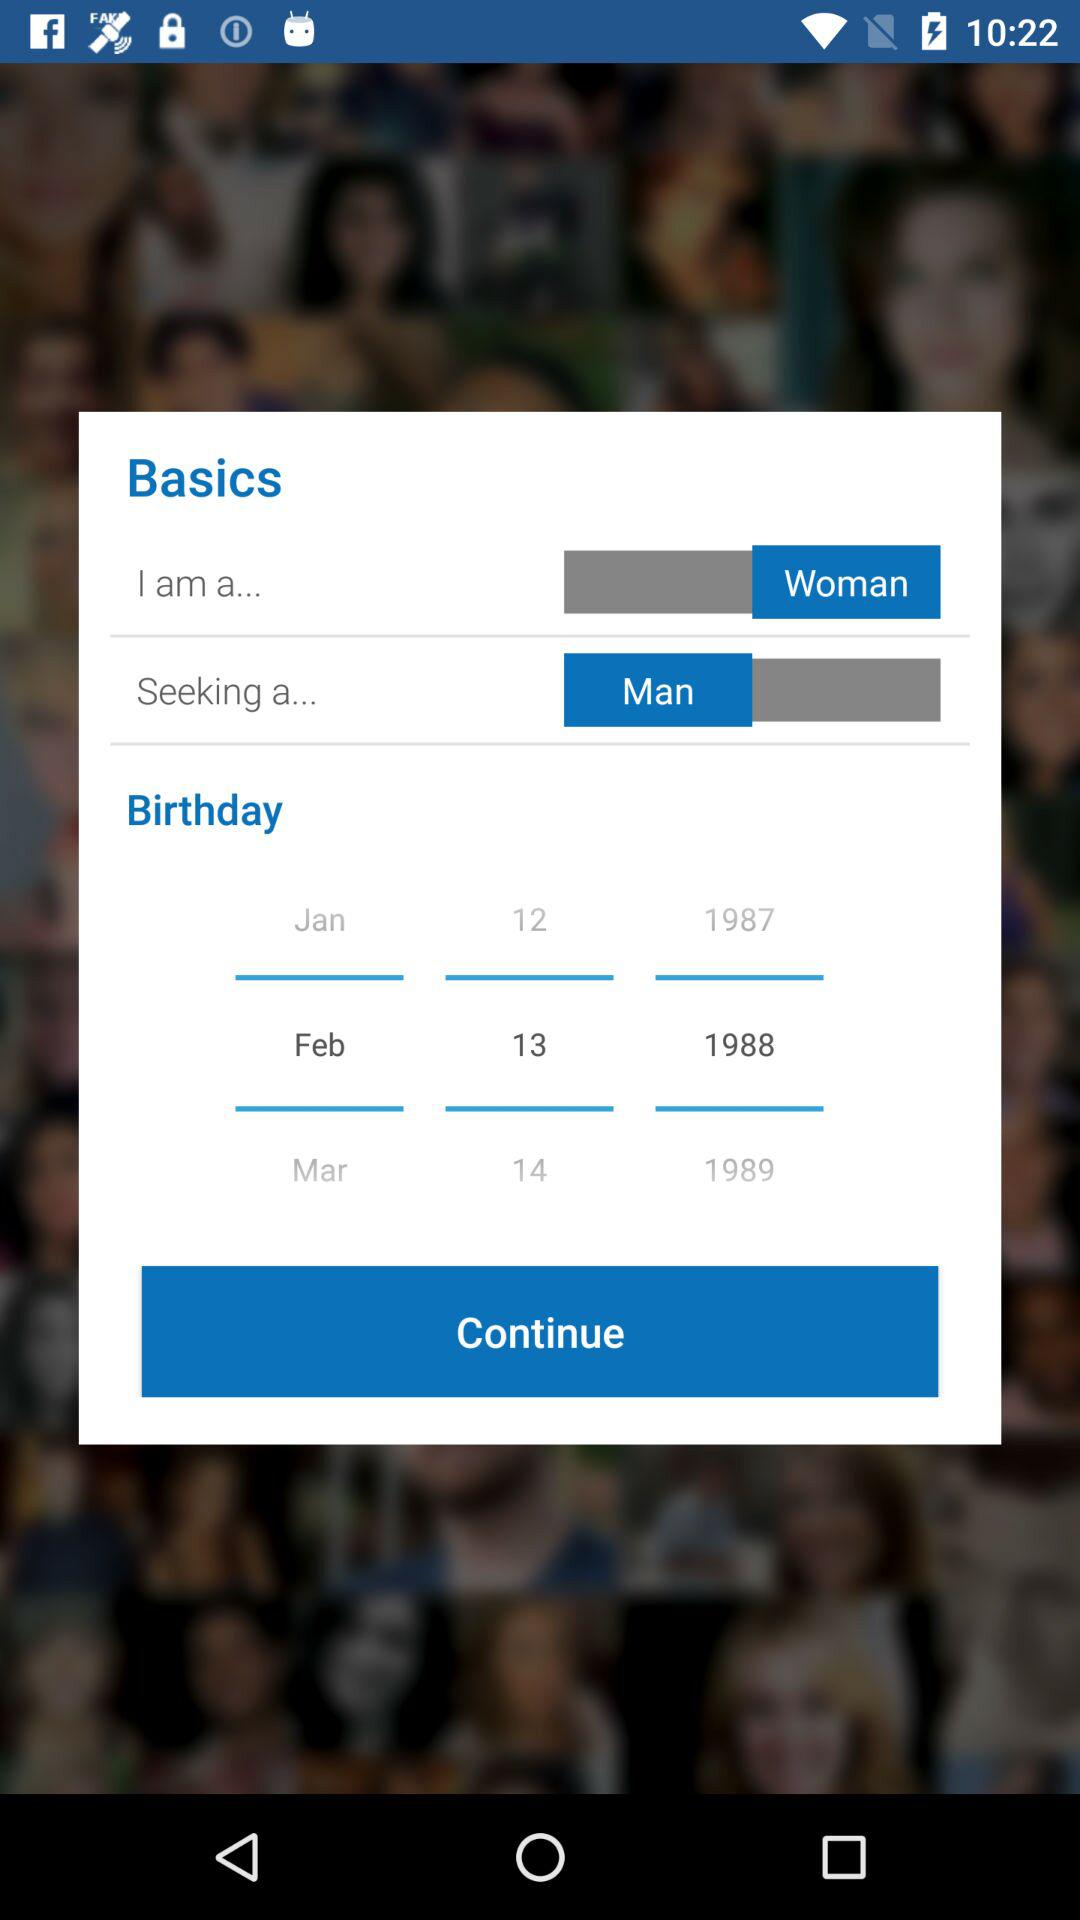How many months are offered for the birthday field?
Answer the question using a single word or phrase. 3 